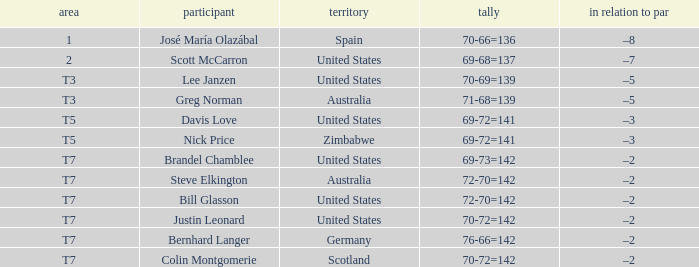Name the Player who has a To par of –2 and a Score of 69-73=142? Brandel Chamblee. 